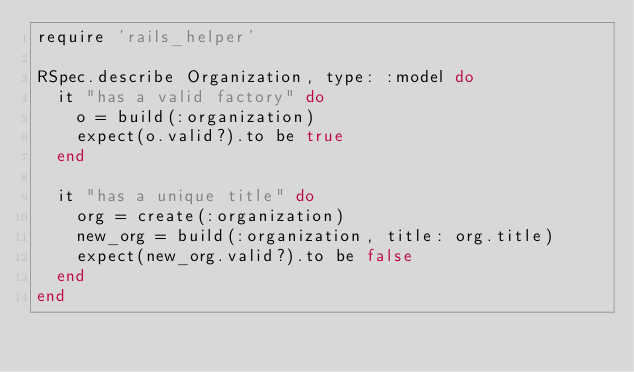Convert code to text. <code><loc_0><loc_0><loc_500><loc_500><_Ruby_>require 'rails_helper'

RSpec.describe Organization, type: :model do
  it "has a valid factory" do
    o = build(:organization)
    expect(o.valid?).to be true
  end

  it "has a unique title" do
    org = create(:organization)
    new_org = build(:organization, title: org.title)
    expect(new_org.valid?).to be false
  end
end
</code> 